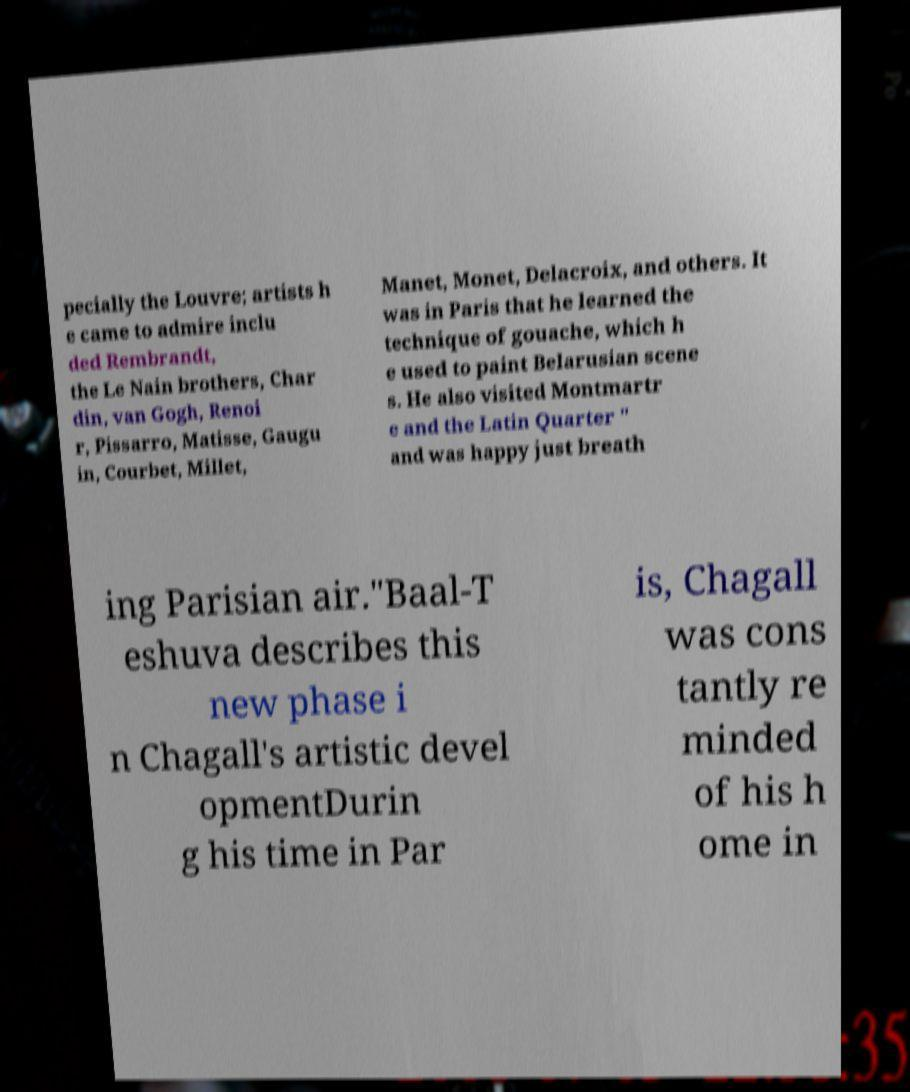I need the written content from this picture converted into text. Can you do that? pecially the Louvre; artists h e came to admire inclu ded Rembrandt, the Le Nain brothers, Char din, van Gogh, Renoi r, Pissarro, Matisse, Gaugu in, Courbet, Millet, Manet, Monet, Delacroix, and others. It was in Paris that he learned the technique of gouache, which h e used to paint Belarusian scene s. He also visited Montmartr e and the Latin Quarter " and was happy just breath ing Parisian air."Baal-T eshuva describes this new phase i n Chagall's artistic devel opmentDurin g his time in Par is, Chagall was cons tantly re minded of his h ome in 